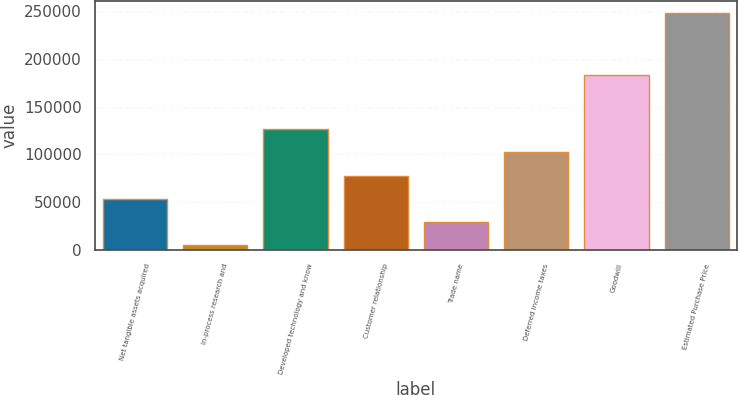<chart> <loc_0><loc_0><loc_500><loc_500><bar_chart><fcel>Net tangible assets acquired<fcel>In-process research and<fcel>Developed technology and know<fcel>Customer relationship<fcel>Trade name<fcel>Deferred income taxes<fcel>Goodwill<fcel>Estimated Purchase Price<nl><fcel>53540<fcel>4900<fcel>126500<fcel>77860<fcel>29220<fcel>102180<fcel>182800<fcel>248100<nl></chart> 